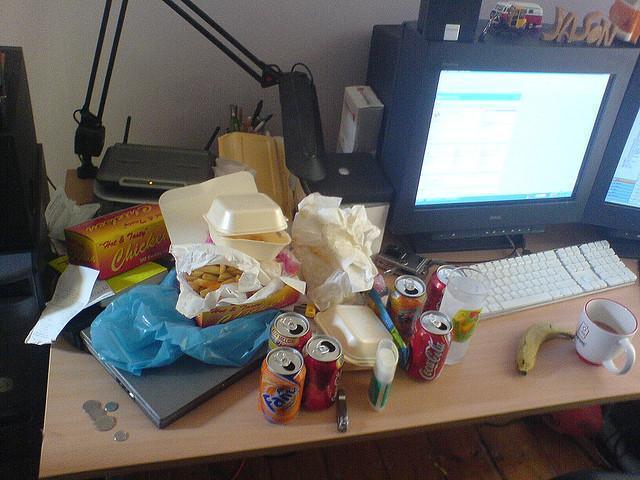Where is Coca-Cola's headquarters located?
Answer the question by selecting the correct answer among the 4 following choices.
Options: Arizona, georgia, utah, maine. Georgia. 